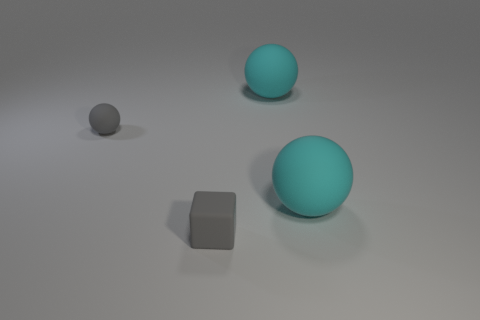Add 2 small things. How many objects exist? 6 Subtract all cubes. How many objects are left? 3 Subtract all small blocks. Subtract all purple metal things. How many objects are left? 3 Add 3 tiny gray spheres. How many tiny gray spheres are left? 4 Add 3 cyan balls. How many cyan balls exist? 5 Subtract 0 cyan cylinders. How many objects are left? 4 